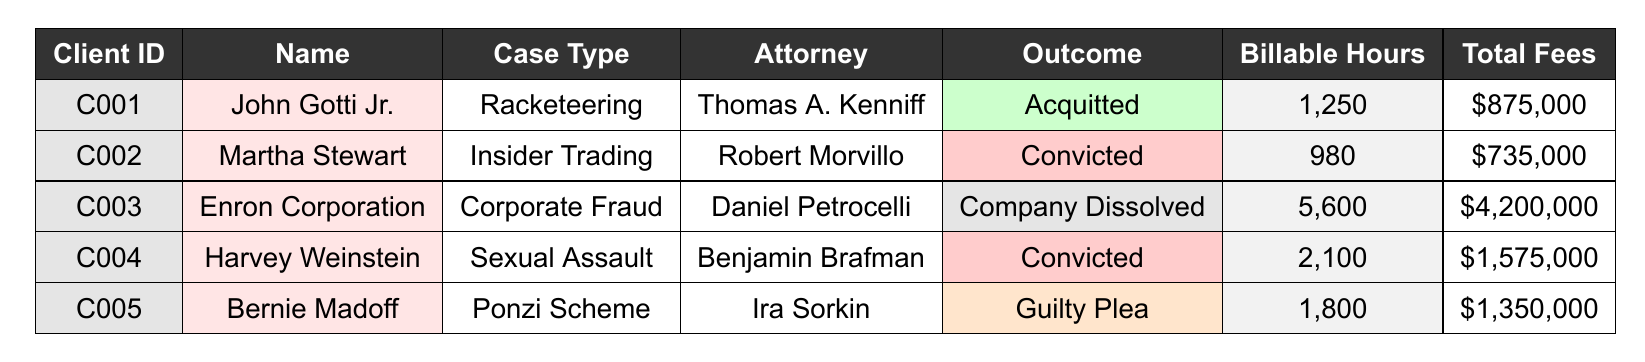What is the outcome of John Gotti Jr.'s case? John Gotti Jr.'s outcome can be found in the "Outcome" column next to his name in the table; it states "Acquitted."
Answer: Acquitted How many billable hours were recorded for Harvey Weinstein's case? To find the number of billable hours for Harvey Weinstein, refer to the "Billable Hours" column next to his name, which shows 2,100 hours.
Answer: 2100 Which client had the highest total fees? By comparing the values in the "Total Fees" column, Enron Corporation has the highest total fees of \$4,200,000, which is greater than the other clients' fees.
Answer: Enron Corporation What was Bernie Madoff convicted of? Bernie Madoff's case can be identified by looking at the "Case Type" associated with his name, which is "Ponzi Scheme."
Answer: Ponzi Scheme Is it true that Martha Stewart was convicted? The "Outcome" column indicates that Martha Stewart's outcome is "Convicted," confirming the truth of the statement.
Answer: Yes Calculate the average number of billable hours for all clients. Add all billable hours: 1250 + 980 + 5600 + 2100 + 1800 = 12530. Then, divide by the number of clients (5), which results in 12530 / 5 = 2506.
Answer: 2506 Which attorney represented clients with a "Convicted" outcome? Review the "Attorney" column and the corresponding "Outcome" column; both Harvey Weinstein and Martha Stewart were represented by Benjamin Brafman and Robert Morvillo respectively, who both had a "Convicted" outcome.
Answer: Benjamin Brafman, Robert Morvillo How many clients had outcomes leading to company dissolution or guilty pleas? Check the "Outcome" column for relevant entries; Enron Corporation (Company Dissolved) and Bernie Madoff (Guilty Plea) total 2 clients.
Answer: 2 What was the total amount billed for all cases? Sum the "Total Fees" for each client: 875000 + 735000 + 4200000 + 1575000 + 1350000 = 8095000.
Answer: 8095000 What is the duration of the case for John Gotti Jr.? Calculate the duration by subtracting the start date (2021-03-15) from the end date (2022-11-30), which is 1 year and approximately 8 months or 1.67 years.
Answer: 1 year and 8 months 